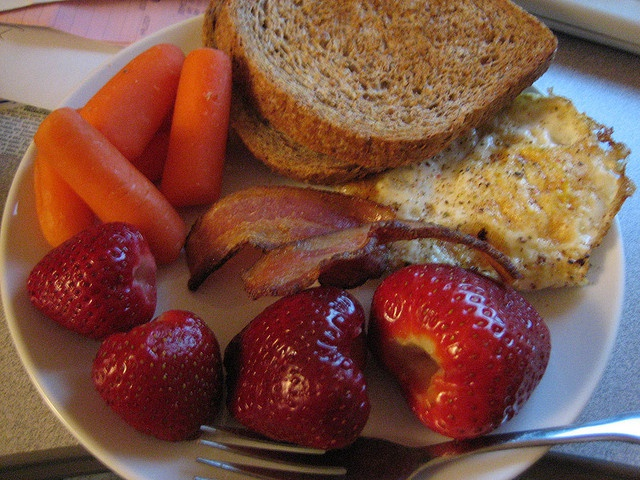Describe the objects in this image and their specific colors. I can see sandwich in darkgray, brown, gray, maroon, and tan tones, sandwich in darkgray, tan, and olive tones, fork in darkgray, black, maroon, gray, and olive tones, carrot in darkgray, brown, and maroon tones, and carrot in darkgray, brown, red, and maroon tones in this image. 